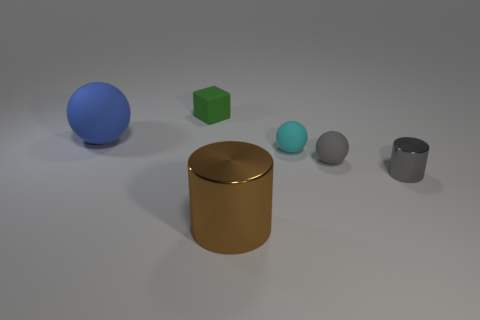There is a sphere that is the same color as the small metallic object; what size is it?
Provide a succinct answer. Small. There is a small gray shiny object; are there any big blue balls to the left of it?
Provide a short and direct response. Yes. The gray shiny thing is what shape?
Give a very brief answer. Cylinder. What is the shape of the big thing that is left of the large object that is right of the rubber object to the left of the small green matte cube?
Give a very brief answer. Sphere. How many other things are there of the same shape as the large brown object?
Keep it short and to the point. 1. There is a large thing that is behind the cyan matte object that is in front of the blue ball; what is its material?
Your answer should be compact. Rubber. Is there any other thing that has the same size as the blue thing?
Offer a very short reply. Yes. Does the gray cylinder have the same material as the tiny thing that is to the left of the large cylinder?
Your response must be concise. No. What is the small object that is both in front of the cyan matte ball and left of the gray shiny thing made of?
Your answer should be very brief. Rubber. What color is the large object that is right of the thing that is left of the tiny green object?
Offer a terse response. Brown. 